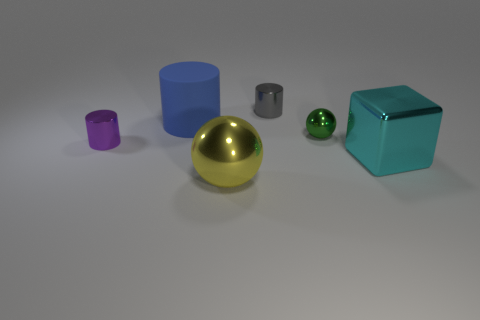There is a gray object that is the same material as the block; what is its size?
Your answer should be very brief. Small. There is a ball that is to the right of the gray thing; what is its size?
Your answer should be compact. Small. What color is the metal cylinder that is the same size as the purple thing?
Provide a succinct answer. Gray. What is the material of the tiny cylinder that is behind the big blue object?
Keep it short and to the point. Metal. There is another shiny object that is the same shape as the tiny green object; what is its size?
Your response must be concise. Large. The other metal thing that is the same shape as the small green object is what color?
Make the answer very short. Yellow. There is a small metal cylinder behind the small purple metallic object; is it the same color as the rubber object?
Your answer should be very brief. No. Is the cyan object the same size as the gray thing?
Your answer should be very brief. No. What is the shape of the yellow object that is made of the same material as the gray cylinder?
Give a very brief answer. Sphere. How many other things are there of the same shape as the cyan thing?
Your response must be concise. 0. 